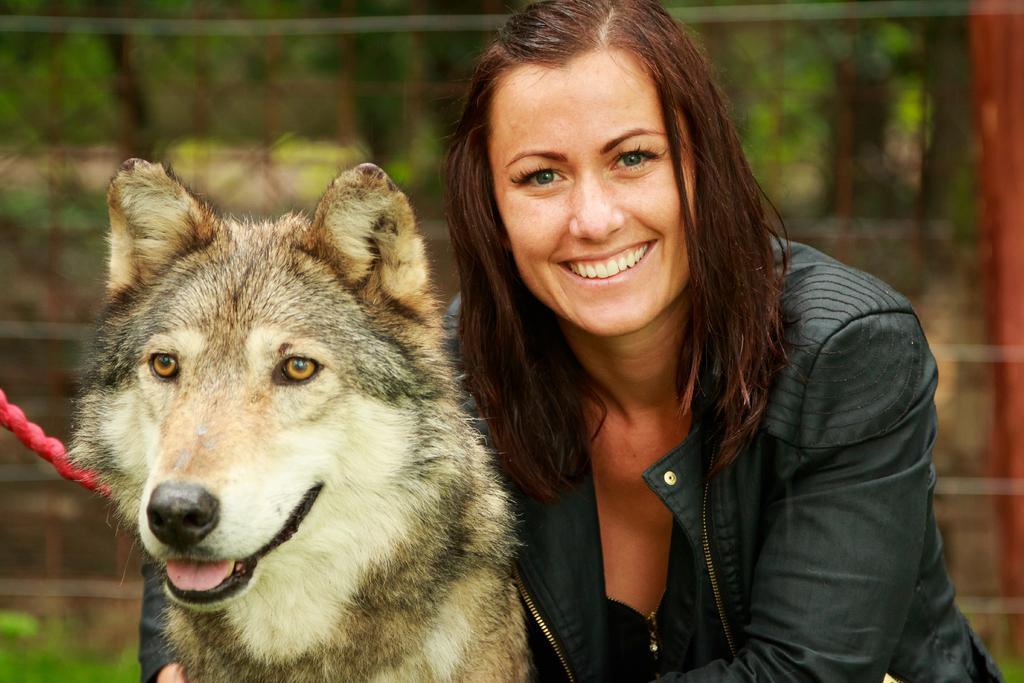In one or two sentences, can you explain what this image depicts? In this image I can see a woman wearing black color dress. I can see dog which is in white,brown and black color. Background is blurred. 